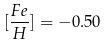Convert formula to latex. <formula><loc_0><loc_0><loc_500><loc_500>[ \frac { F e } { H } ] = - 0 . 5 0</formula> 